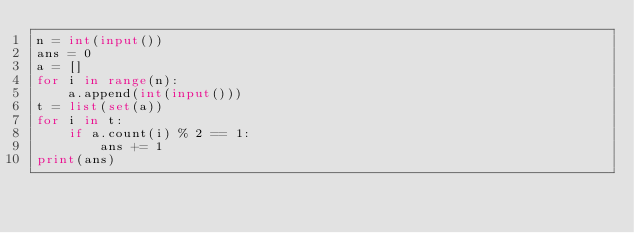Convert code to text. <code><loc_0><loc_0><loc_500><loc_500><_Python_>n = int(input())
ans = 0
a = []
for i in range(n):
    a.append(int(input()))
t = list(set(a))
for i in t:
    if a.count(i) % 2 == 1:
        ans += 1
print(ans)</code> 